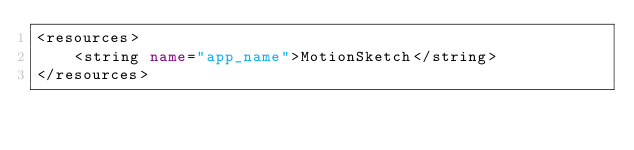<code> <loc_0><loc_0><loc_500><loc_500><_XML_><resources>
    <string name="app_name">MotionSketch</string>
</resources>
</code> 